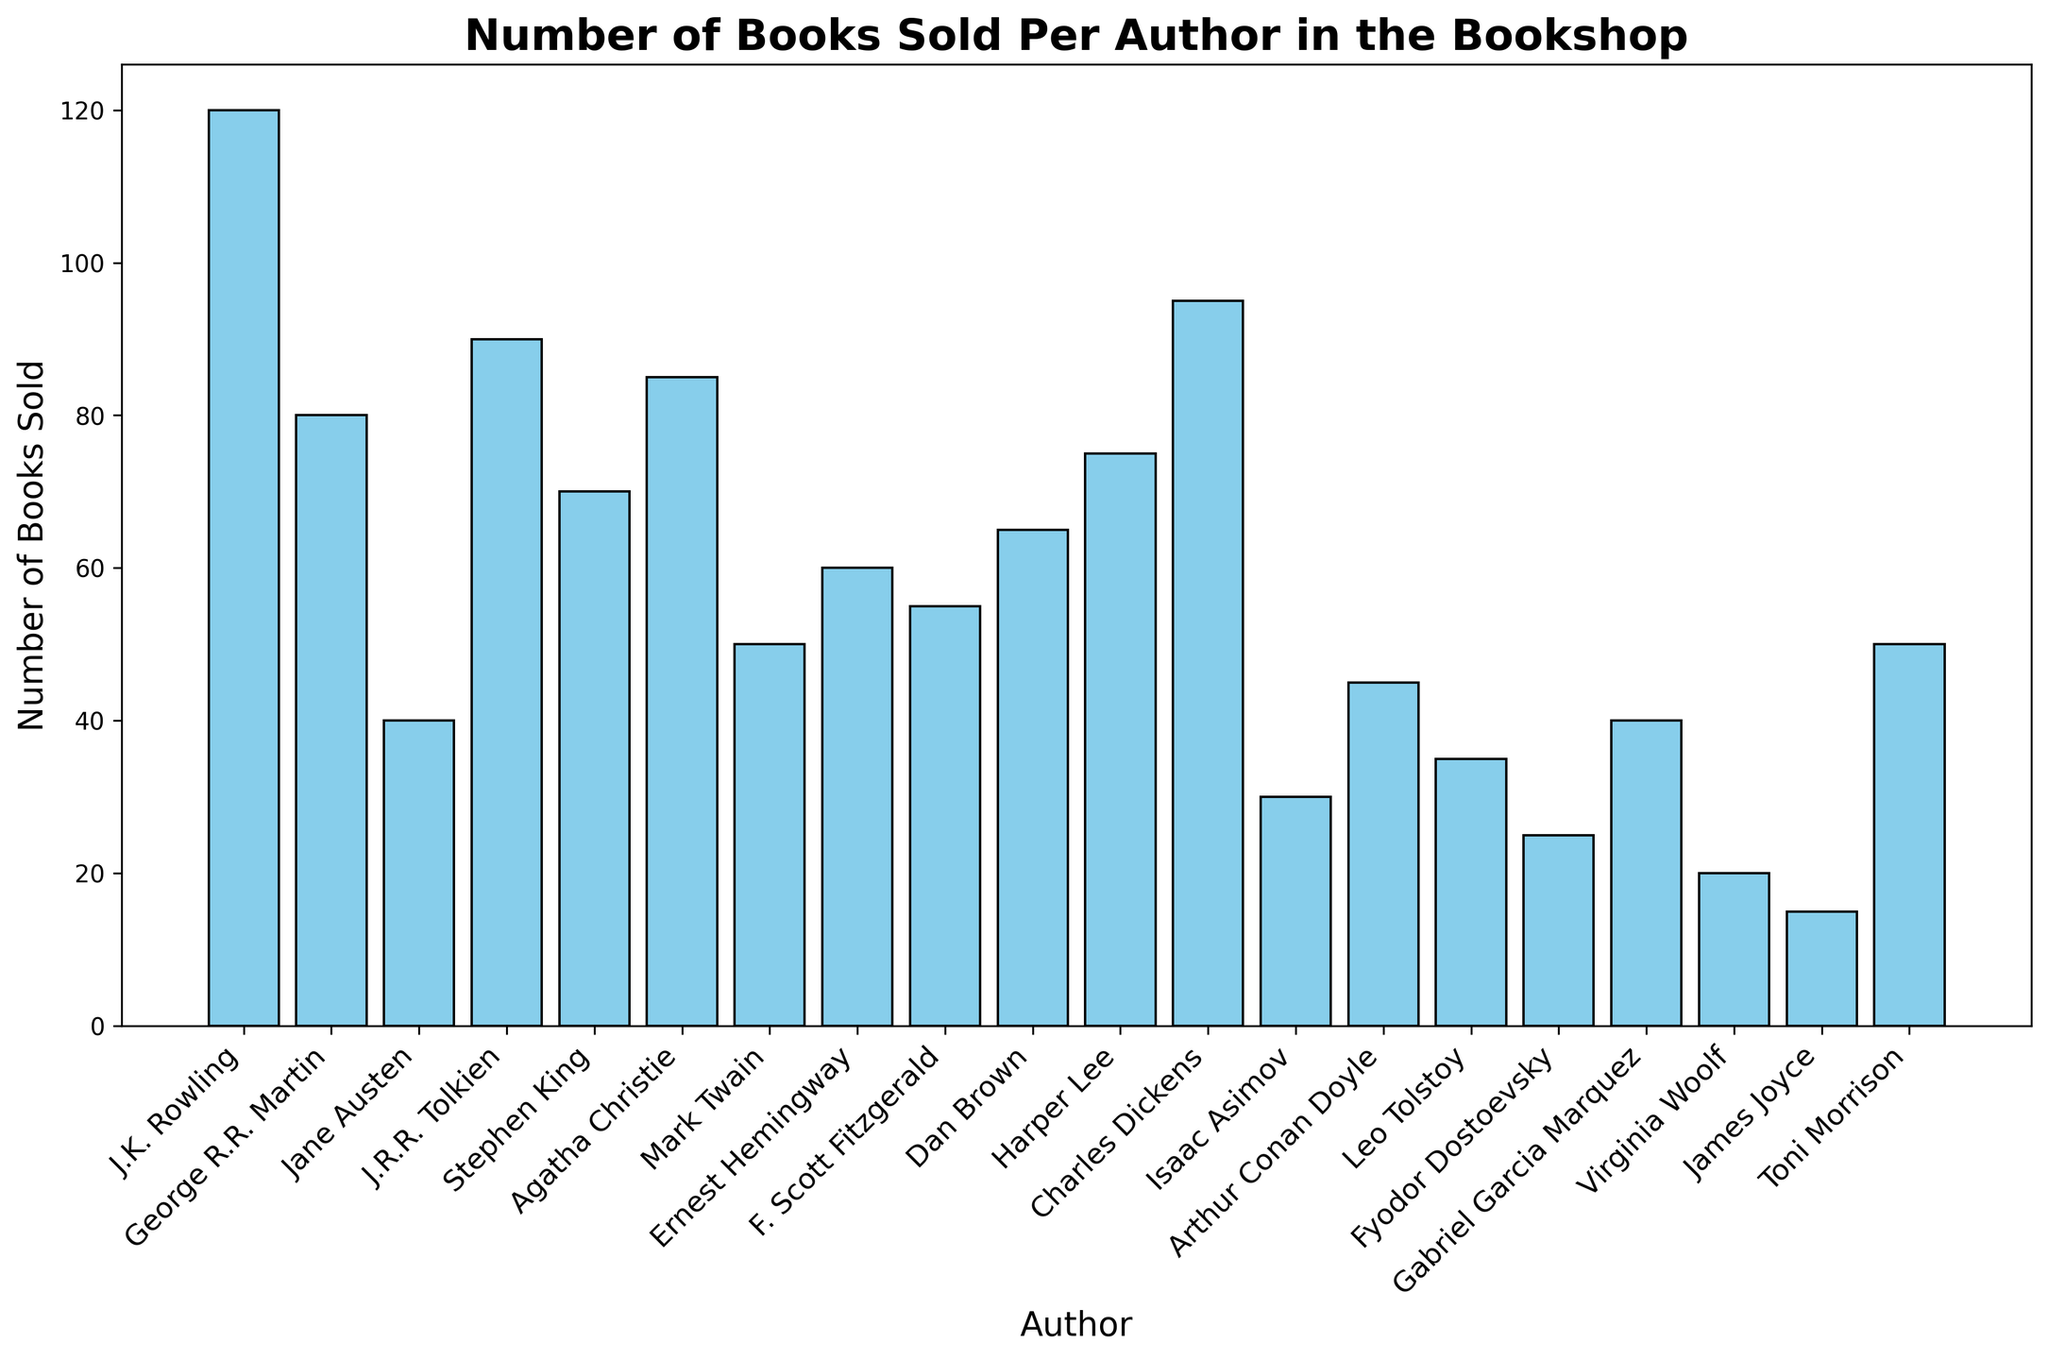What is the total number of books sold by J.K. Rowling and George R.R. Martin combined? The number of books sold by J.K. Rowling is 120, and the number of books sold by George R.R. Martin is 80. Adding those together: 120 + 80 = 200
Answer: 200 Which author has sold the highest number of books? By examining the heights of the bars, J.K. Rowling's bar is the tallest. Therefore, she sold the most books.
Answer: J.K. Rowling How many books has Jane Austen sold compared to James Joyce? Jane Austen has sold 40 books, while James Joyce has sold 15. The difference is 40 - 15 = 25 books.
Answer: 25 What’s the average number of books sold by the top three authors? The top three authors by books sold are J.K. Rowling (120), Charles Dickens (95), and J.R.R. Tolkien (90). Summing these: 120 + 95 + 90 = 305. The average is 305 / 3 = 101.67
Answer: 101.67 Which authors sold more than 80 books? The authors with bars higher than the 80 mark are J.K. Rowling (120), J.R.R. Tolkien (90), Agatha Christie (85), and Charles Dickens (95).
Answer: J.K. Rowling, J.R.R. Tolkien, Agatha Christie, Charles Dickens Which author's bar is closest in height to Ernest Hemingway's? Ernest Hemingway sold 60 books. The authors nearest this number are Dan Brown and Harper Lee, both slightly higher at 65 and 75, respectively. Dan Brown is closest.
Answer: Dan Brown How does the total number of books sold by Stephen King and Agatha Christie compare? Stephen King sold 70 books and Agatha Christie sold 85. Total for both is 70 + 85 = 155.
Answer: 155 What is the range of the number of books sold by the authors? The difference between the maximum (J.K. Rowling with 120) and minimum (James Joyce with 15) number of books sold is 120 - 15 = 105
Answer: 105 Which author sold 40 books, and how many authors sold fewer books than that? Jane Austen and Gabriel Garcia Marquez each sold 40 books. The authors who sold fewer are Isaac Asimov, Leo Tolstoy, Fyodor Dostoevsky, Virginia Woolf, and James Joyce—5 authors in total.
Answer: Jane Austen and Gabriel Garcia Marquez, 5 What is the median number of books sold by the authors? With 20 authors, the median will be the average of the 10th and 11th highest values. Arranged in order: [15, 20, 25, 30, 35, 40, 40, 45, 50, 50, 55, 60, 65, 70, 75, 80, 85, 90, 95, 120], the 10th and 11th are 50 and 55. The median is (50 + 55) / 2 = 52.5
Answer: 52.5 